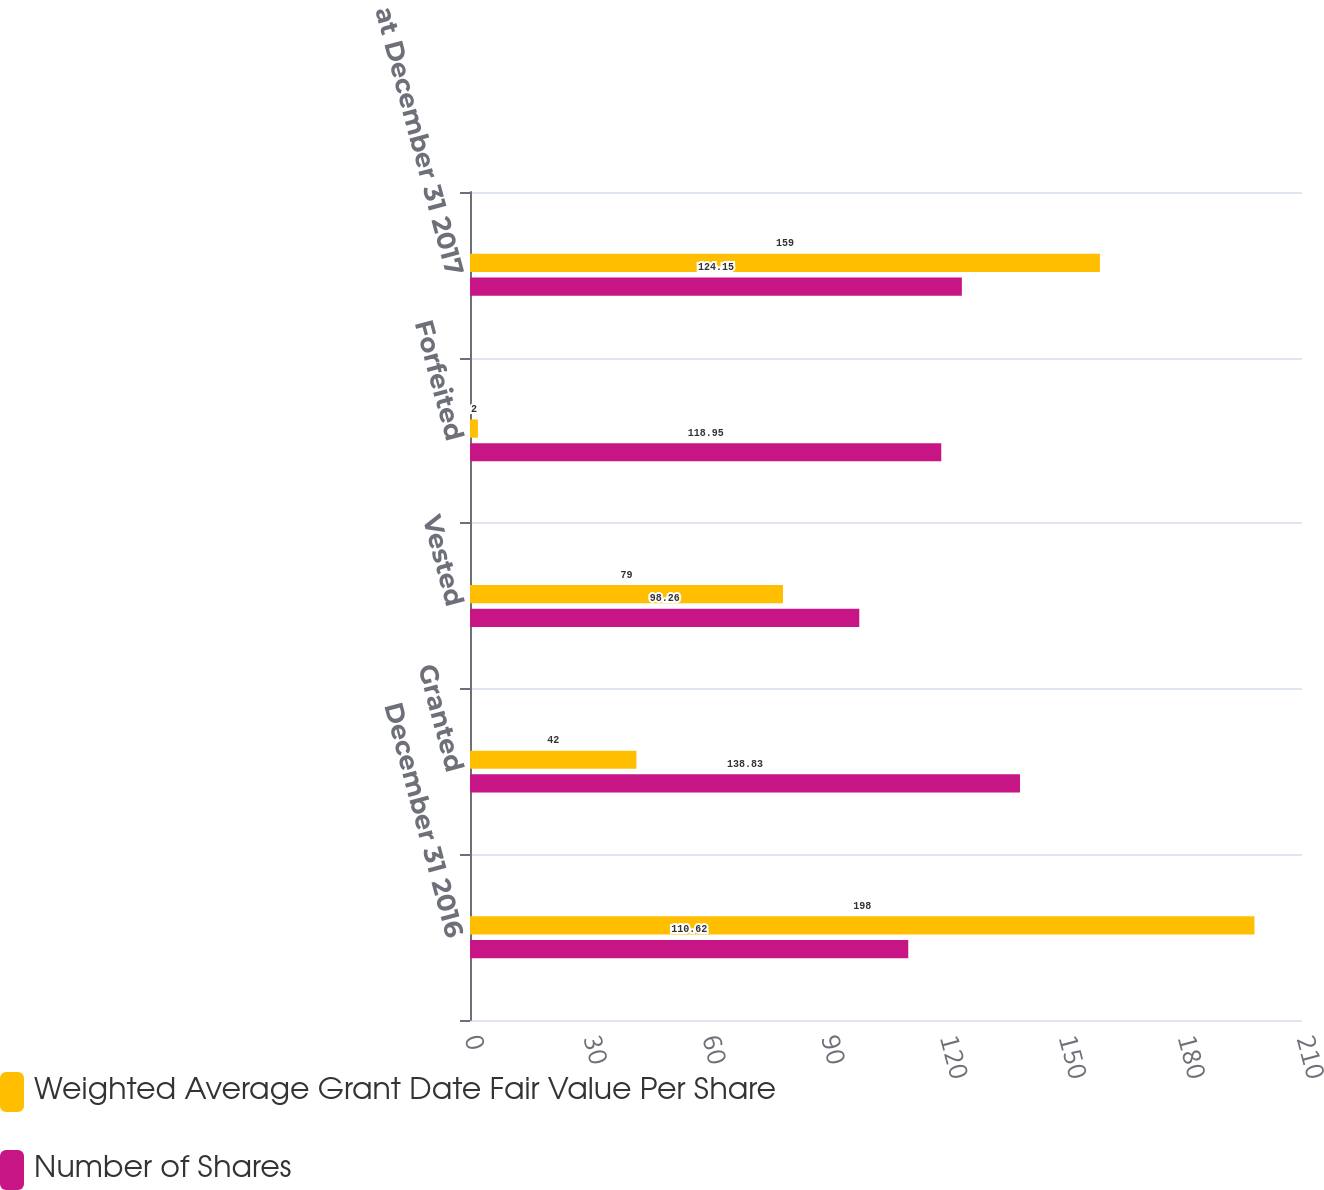Convert chart to OTSL. <chart><loc_0><loc_0><loc_500><loc_500><stacked_bar_chart><ecel><fcel>December 31 2016<fcel>Granted<fcel>Vested<fcel>Forfeited<fcel>Balance at December 31 2017<nl><fcel>Weighted Average Grant Date Fair Value Per Share<fcel>198<fcel>42<fcel>79<fcel>2<fcel>159<nl><fcel>Number of Shares<fcel>110.62<fcel>138.83<fcel>98.26<fcel>118.95<fcel>124.15<nl></chart> 